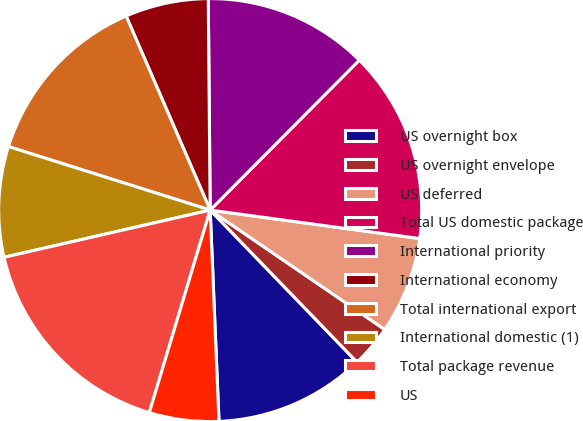Convert chart. <chart><loc_0><loc_0><loc_500><loc_500><pie_chart><fcel>US overnight box<fcel>US overnight envelope<fcel>US deferred<fcel>Total US domestic package<fcel>International priority<fcel>International economy<fcel>Total international export<fcel>International domestic (1)<fcel>Total package revenue<fcel>US<nl><fcel>11.56%<fcel>3.23%<fcel>7.4%<fcel>14.69%<fcel>12.6%<fcel>6.36%<fcel>13.64%<fcel>8.44%<fcel>16.77%<fcel>5.31%<nl></chart> 